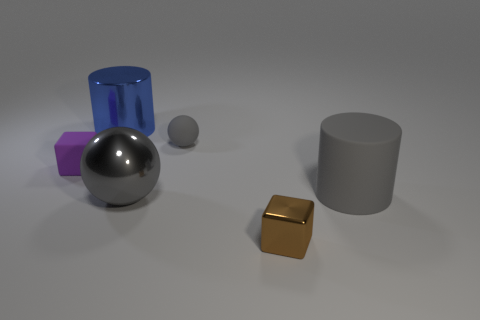Add 2 small gray objects. How many objects exist? 8 Subtract all balls. How many objects are left? 4 Subtract all gray rubber things. Subtract all small purple objects. How many objects are left? 3 Add 6 small gray matte objects. How many small gray matte objects are left? 7 Add 2 tiny cyan matte spheres. How many tiny cyan matte spheres exist? 2 Subtract 0 brown cylinders. How many objects are left? 6 